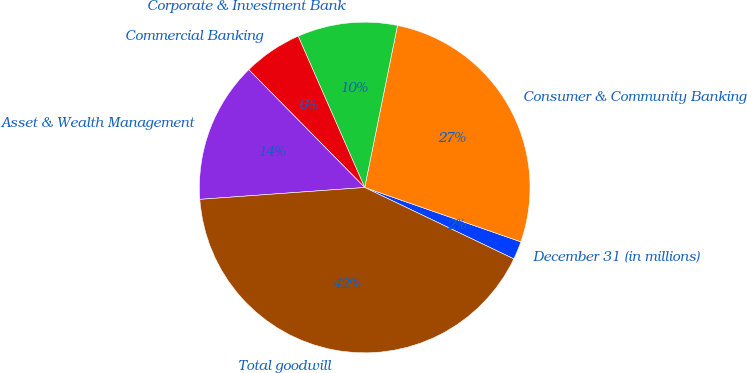Convert chart. <chart><loc_0><loc_0><loc_500><loc_500><pie_chart><fcel>December 31 (in millions)<fcel>Consumer & Community Banking<fcel>Corporate & Investment Bank<fcel>Commercial Banking<fcel>Asset & Wealth Management<fcel>Total goodwill<nl><fcel>1.78%<fcel>27.15%<fcel>9.77%<fcel>5.78%<fcel>13.77%<fcel>41.75%<nl></chart> 